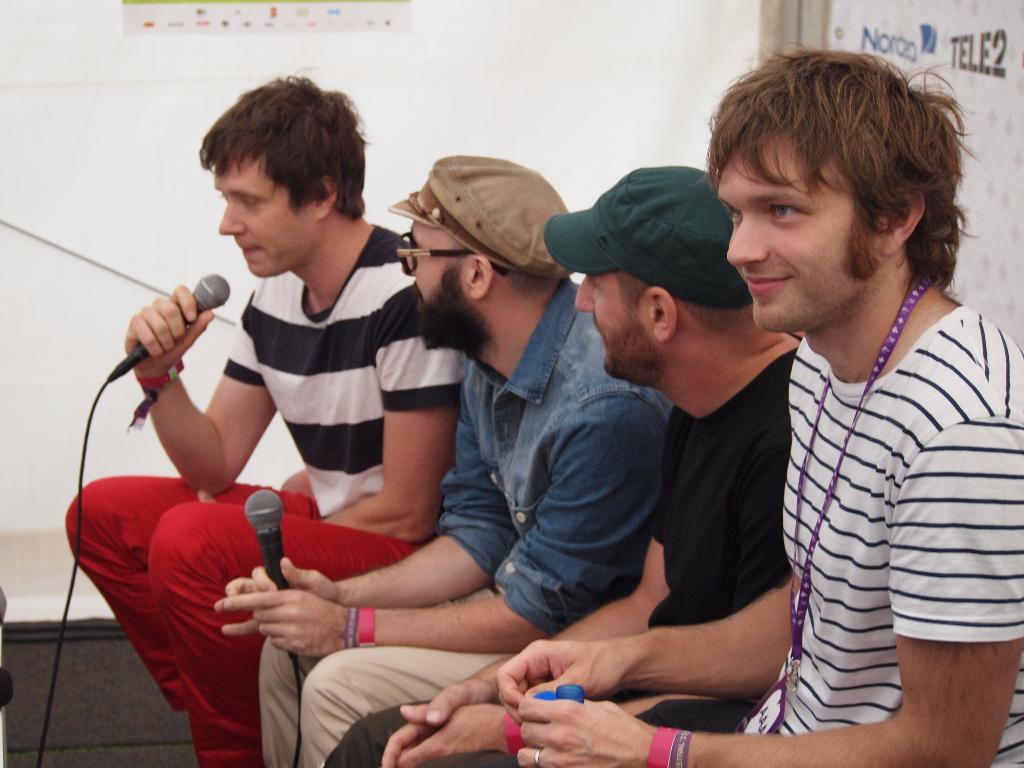How many people are in the image? There are four men in the image. What are the men doing in the image? The men are sitting on chairs. What can be seen on the men's hands? The men are wearing wrist bands on their hands. What is one of the men holding in his hand? One man is holding a microphone in his hand. What type of hydrant can be seen in the image? There is no hydrant present in the image. How does the rake help the men in the image? There is no rake present in the image, so it cannot help the men. 